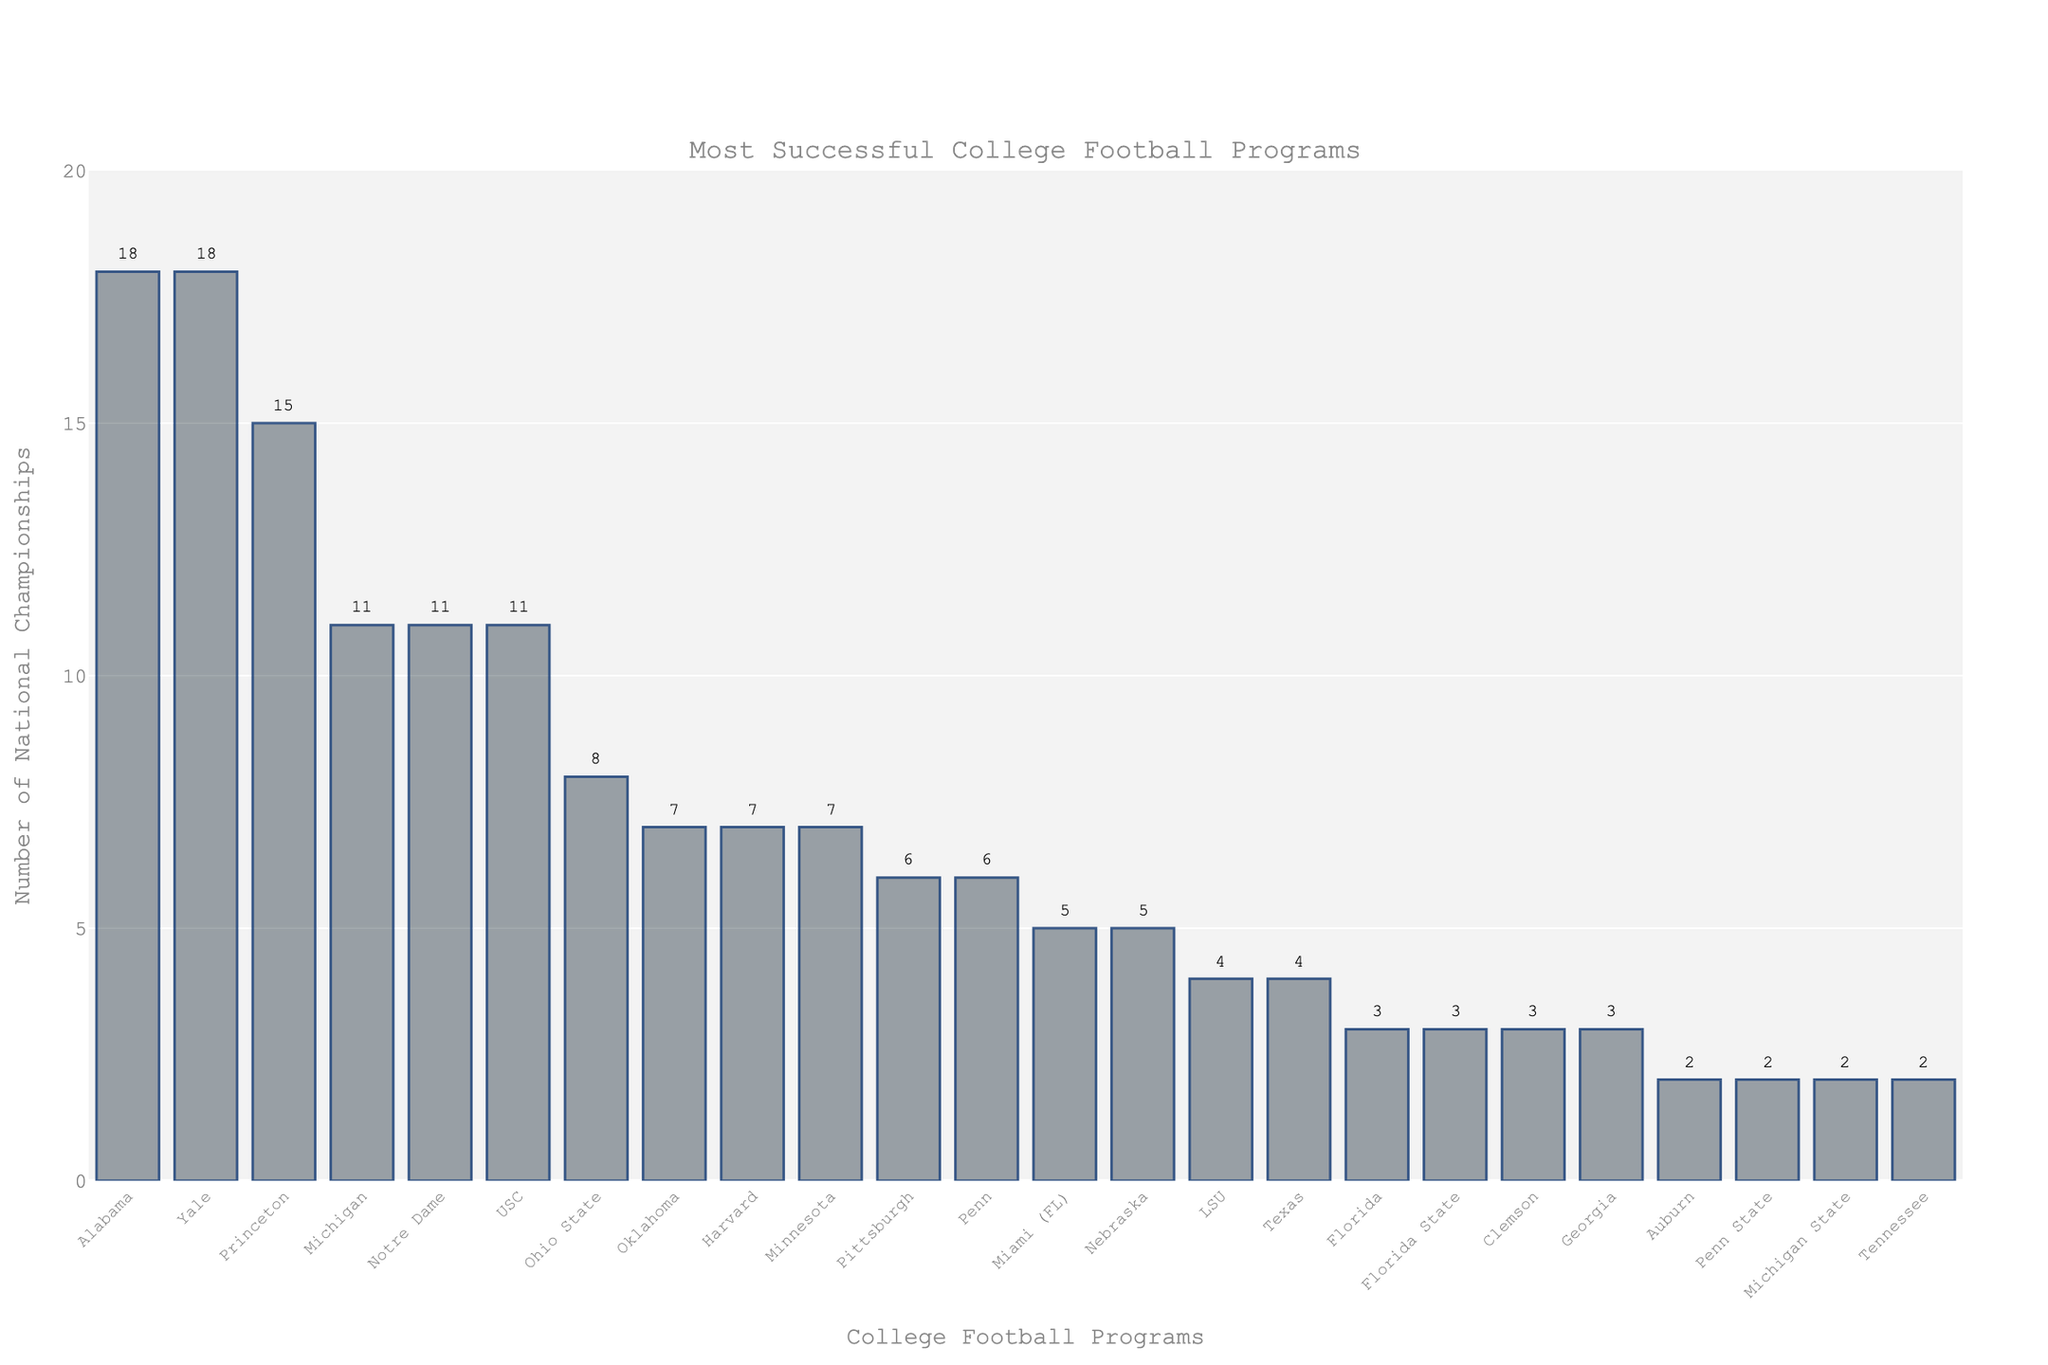Which two programs have the highest number of national championships? Identify the tall bars in the figure and look at their labels to find the programs with the highest values. Alabama and Yale both have the highest at 18 national championships.
Answer: Alabama and Yale Which programs have won exactly 11 national championships? Find the bars that reach the height corresponding to 11 championships and look at their labels. Michigan, Notre Dame, and USC each have won 11 national championships.
Answer: Michigan, Notre Dame, USC Which program has won more national championships, Oklahoma or Nebraska? Compare the height of the bars for Oklahoma and Nebraska. Oklahoma has a taller bar (7 championships) compared to Nebraska (5 championships).
Answer: Oklahoma How many total national championships have been won by Alabama, Yale, and Oklahoma combined? Add the championships of Alabama (18), Yale (18), and Oklahoma (7): 18 + 18 + 7 = 43.
Answer: 43 What’s the difference in national championships between Princeton and Georgia? Subtract the number of championships for Georgia (3) from that for Princeton (15): 15 - 3 = 12.
Answer: 12 Are there more programs with exactly 2 national championships or those with exactly 3? Count the bars reaching the height corresponding to 2 championships (Auburn, Tennessee, Penn State, Michigan State) which are 4, and those reaching 3 championships (Florida, Florida State, Clemson, Georgia) which are also 4. Both counts are equal.
Answer: They are equal Arrange the top three programs with the most national championships in descending order. Identify the programs with the three tallest bars and list them from highest to lowest by number of championships. Alabama and Yale both have the highest (18), followed by Princeton (15).
Answer: Alabama, Yale, Princeton What percentage of the total national championships listed have been won by Harvard? Calculate the total number of championships listed by summing all values. Then divide Harvard’s championships (7) by this total and multiply by 100. Total championships = 18+18+15+11+11+11+8+7+7+7+6+6+5+5+4+4+3+3+3+3+2+2+2+2 = 165. Percentage = (7/165) * 100 ≈ 4.24%.
Answer: 4.24% Which program has the fewest number of national championships among those listed, and how many do they have? Look for the shortest bars in the figure, which indicate the programs with the fewest championships. Programs with the shortest bars are Auburn, Penn State, Michigan State, and Tennessee, each with 2 championships.
Answer: Auburn, Penn State, Michigan State, Tennessee 